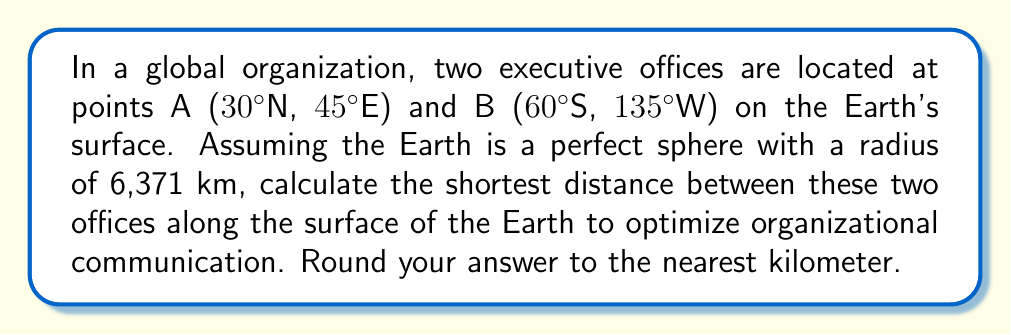Solve this math problem. To solve this problem, we need to use the great circle distance formula, which gives the shortest path between two points on a sphere. The steps are as follows:

1) Convert the latitudes and longitudes to radians:
   $\phi_1 = 30° \cdot \frac{\pi}{180} = 0.5236$ rad
   $\lambda_1 = 45° \cdot \frac{\pi}{180} = 0.7854$ rad
   $\phi_2 = -60° \cdot \frac{\pi}{180} = -1.0472$ rad
   $\lambda_2 = -135° \cdot \frac{\pi}{180} = -2.3562$ rad

2) Calculate the central angle $\Delta\sigma$ using the Haversine formula:
   $$\Delta\sigma = 2 \arcsin\left(\sqrt{\sin^2\left(\frac{\phi_2-\phi_1}{2}\right) + \cos(\phi_1)\cos(\phi_2)\sin^2\left(\frac{\lambda_2-\lambda_1}{2}\right)}\right)$$

3) Substitute the values:
   $$\Delta\sigma = 2 \arcsin\left(\sqrt{\sin^2\left(\frac{-1.0472-0.5236}{2}\right) + \cos(0.5236)\cos(-1.0472)\sin^2\left(\frac{-2.3562-0.7854}{2}\right)}\right)$$

4) Calculate:
   $\Delta\sigma \approx 2.6961$ radians

5) The distance $d$ is then given by:
   $d = R \cdot \Delta\sigma$
   where $R$ is the radius of the Earth (6,371 km)

6) Calculate the final distance:
   $d = 6,371 \cdot 2.6961 \approx 17,175.8$ km

7) Rounding to the nearest kilometer:
   $d \approx 17,176$ km
Answer: 17,176 km 